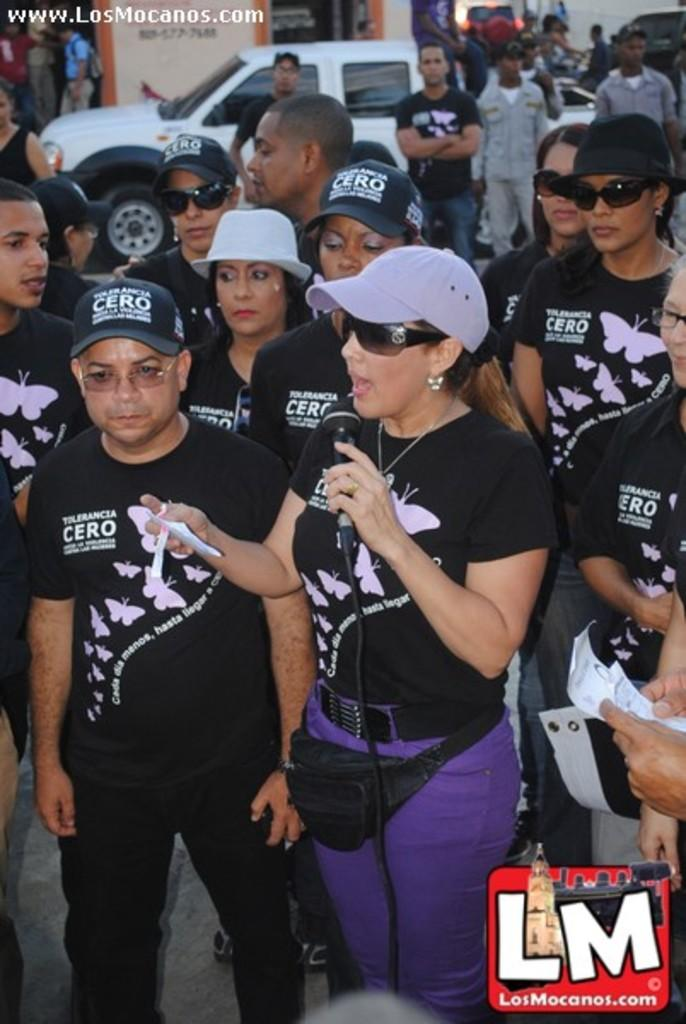How many people are present in the image? There are many people in the image. What are some people wearing in the image? Some people are wearing caps in the image. What else can be seen in the image besides people? There are vehicles in the image. What is the person holding the microphone doing? The person holding the microphone is speaking into it. What types of toys can be seen in the image? There are no toys present in the image. Can you hear the person crying while speaking into the microphone? The image is a still image, so there is no audio to determine if the person is crying or not. 